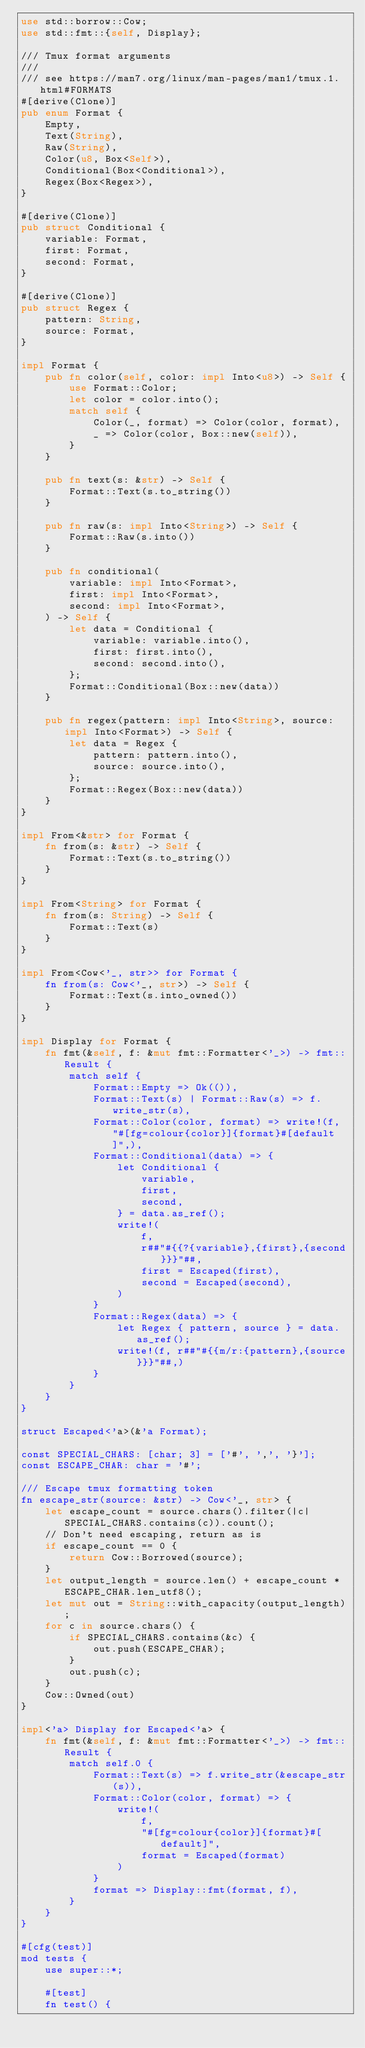<code> <loc_0><loc_0><loc_500><loc_500><_Rust_>use std::borrow::Cow;
use std::fmt::{self, Display};

/// Tmux format arguments
///
/// see https://man7.org/linux/man-pages/man1/tmux.1.html#FORMATS
#[derive(Clone)]
pub enum Format {
    Empty,
    Text(String),
    Raw(String),
    Color(u8, Box<Self>),
    Conditional(Box<Conditional>),
    Regex(Box<Regex>),
}

#[derive(Clone)]
pub struct Conditional {
    variable: Format,
    first: Format,
    second: Format,
}

#[derive(Clone)]
pub struct Regex {
    pattern: String,
    source: Format,
}

impl Format {
    pub fn color(self, color: impl Into<u8>) -> Self {
        use Format::Color;
        let color = color.into();
        match self {
            Color(_, format) => Color(color, format),
            _ => Color(color, Box::new(self)),
        }
    }

    pub fn text(s: &str) -> Self {
        Format::Text(s.to_string())
    }

    pub fn raw(s: impl Into<String>) -> Self {
        Format::Raw(s.into())
    }

    pub fn conditional(
        variable: impl Into<Format>,
        first: impl Into<Format>,
        second: impl Into<Format>,
    ) -> Self {
        let data = Conditional {
            variable: variable.into(),
            first: first.into(),
            second: second.into(),
        };
        Format::Conditional(Box::new(data))
    }

    pub fn regex(pattern: impl Into<String>, source: impl Into<Format>) -> Self {
        let data = Regex {
            pattern: pattern.into(),
            source: source.into(),
        };
        Format::Regex(Box::new(data))
    }
}

impl From<&str> for Format {
    fn from(s: &str) -> Self {
        Format::Text(s.to_string())
    }
}

impl From<String> for Format {
    fn from(s: String) -> Self {
        Format::Text(s)
    }
}

impl From<Cow<'_, str>> for Format {
    fn from(s: Cow<'_, str>) -> Self {
        Format::Text(s.into_owned())
    }
}

impl Display for Format {
    fn fmt(&self, f: &mut fmt::Formatter<'_>) -> fmt::Result {
        match self {
            Format::Empty => Ok(()),
            Format::Text(s) | Format::Raw(s) => f.write_str(s),
            Format::Color(color, format) => write!(f, "#[fg=colour{color}]{format}#[default]",),
            Format::Conditional(data) => {
                let Conditional {
                    variable,
                    first,
                    second,
                } = data.as_ref();
                write!(
                    f,
                    r##"#{{?{variable},{first},{second}}}"##,
                    first = Escaped(first),
                    second = Escaped(second),
                )
            }
            Format::Regex(data) => {
                let Regex { pattern, source } = data.as_ref();
                write!(f, r##"#{{m/r:{pattern},{source}}}"##,)
            }
        }
    }
}

struct Escaped<'a>(&'a Format);

const SPECIAL_CHARS: [char; 3] = ['#', ',', '}'];
const ESCAPE_CHAR: char = '#';

/// Escape tmux formatting token
fn escape_str(source: &str) -> Cow<'_, str> {
    let escape_count = source.chars().filter(|c| SPECIAL_CHARS.contains(c)).count();
    // Don't need escaping, return as is
    if escape_count == 0 {
        return Cow::Borrowed(source);
    }
    let output_length = source.len() + escape_count * ESCAPE_CHAR.len_utf8();
    let mut out = String::with_capacity(output_length);
    for c in source.chars() {
        if SPECIAL_CHARS.contains(&c) {
            out.push(ESCAPE_CHAR);
        }
        out.push(c);
    }
    Cow::Owned(out)
}

impl<'a> Display for Escaped<'a> {
    fn fmt(&self, f: &mut fmt::Formatter<'_>) -> fmt::Result {
        match self.0 {
            Format::Text(s) => f.write_str(&escape_str(s)),
            Format::Color(color, format) => {
                write!(
                    f,
                    "#[fg=colour{color}]{format}#[default]",
                    format = Escaped(format)
                )
            }
            format => Display::fmt(format, f),
        }
    }
}

#[cfg(test)]
mod tests {
    use super::*;

    #[test]
    fn test() {</code> 